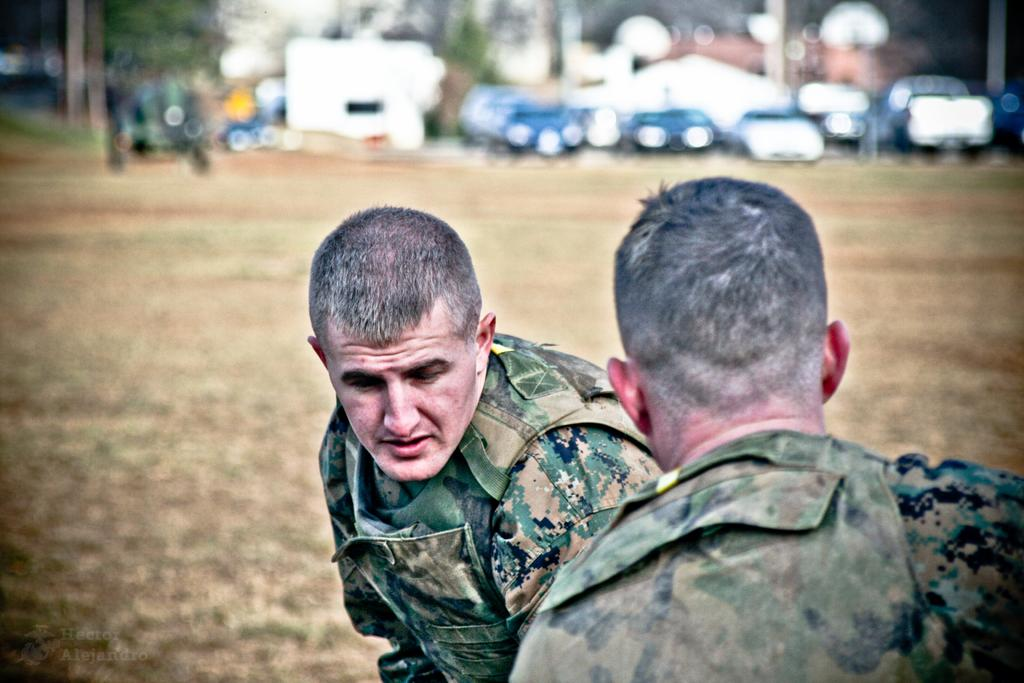How many people are present in the image? There are two people in the image. What are the people wearing? The people are wearing uniforms. What can be seen in the background of the image? There are vehicles and trees in the background of the image. Where is the yam being stored in the image? There is no yam present in the image. Can you see any cows in the image? There are no cows present in the image. 